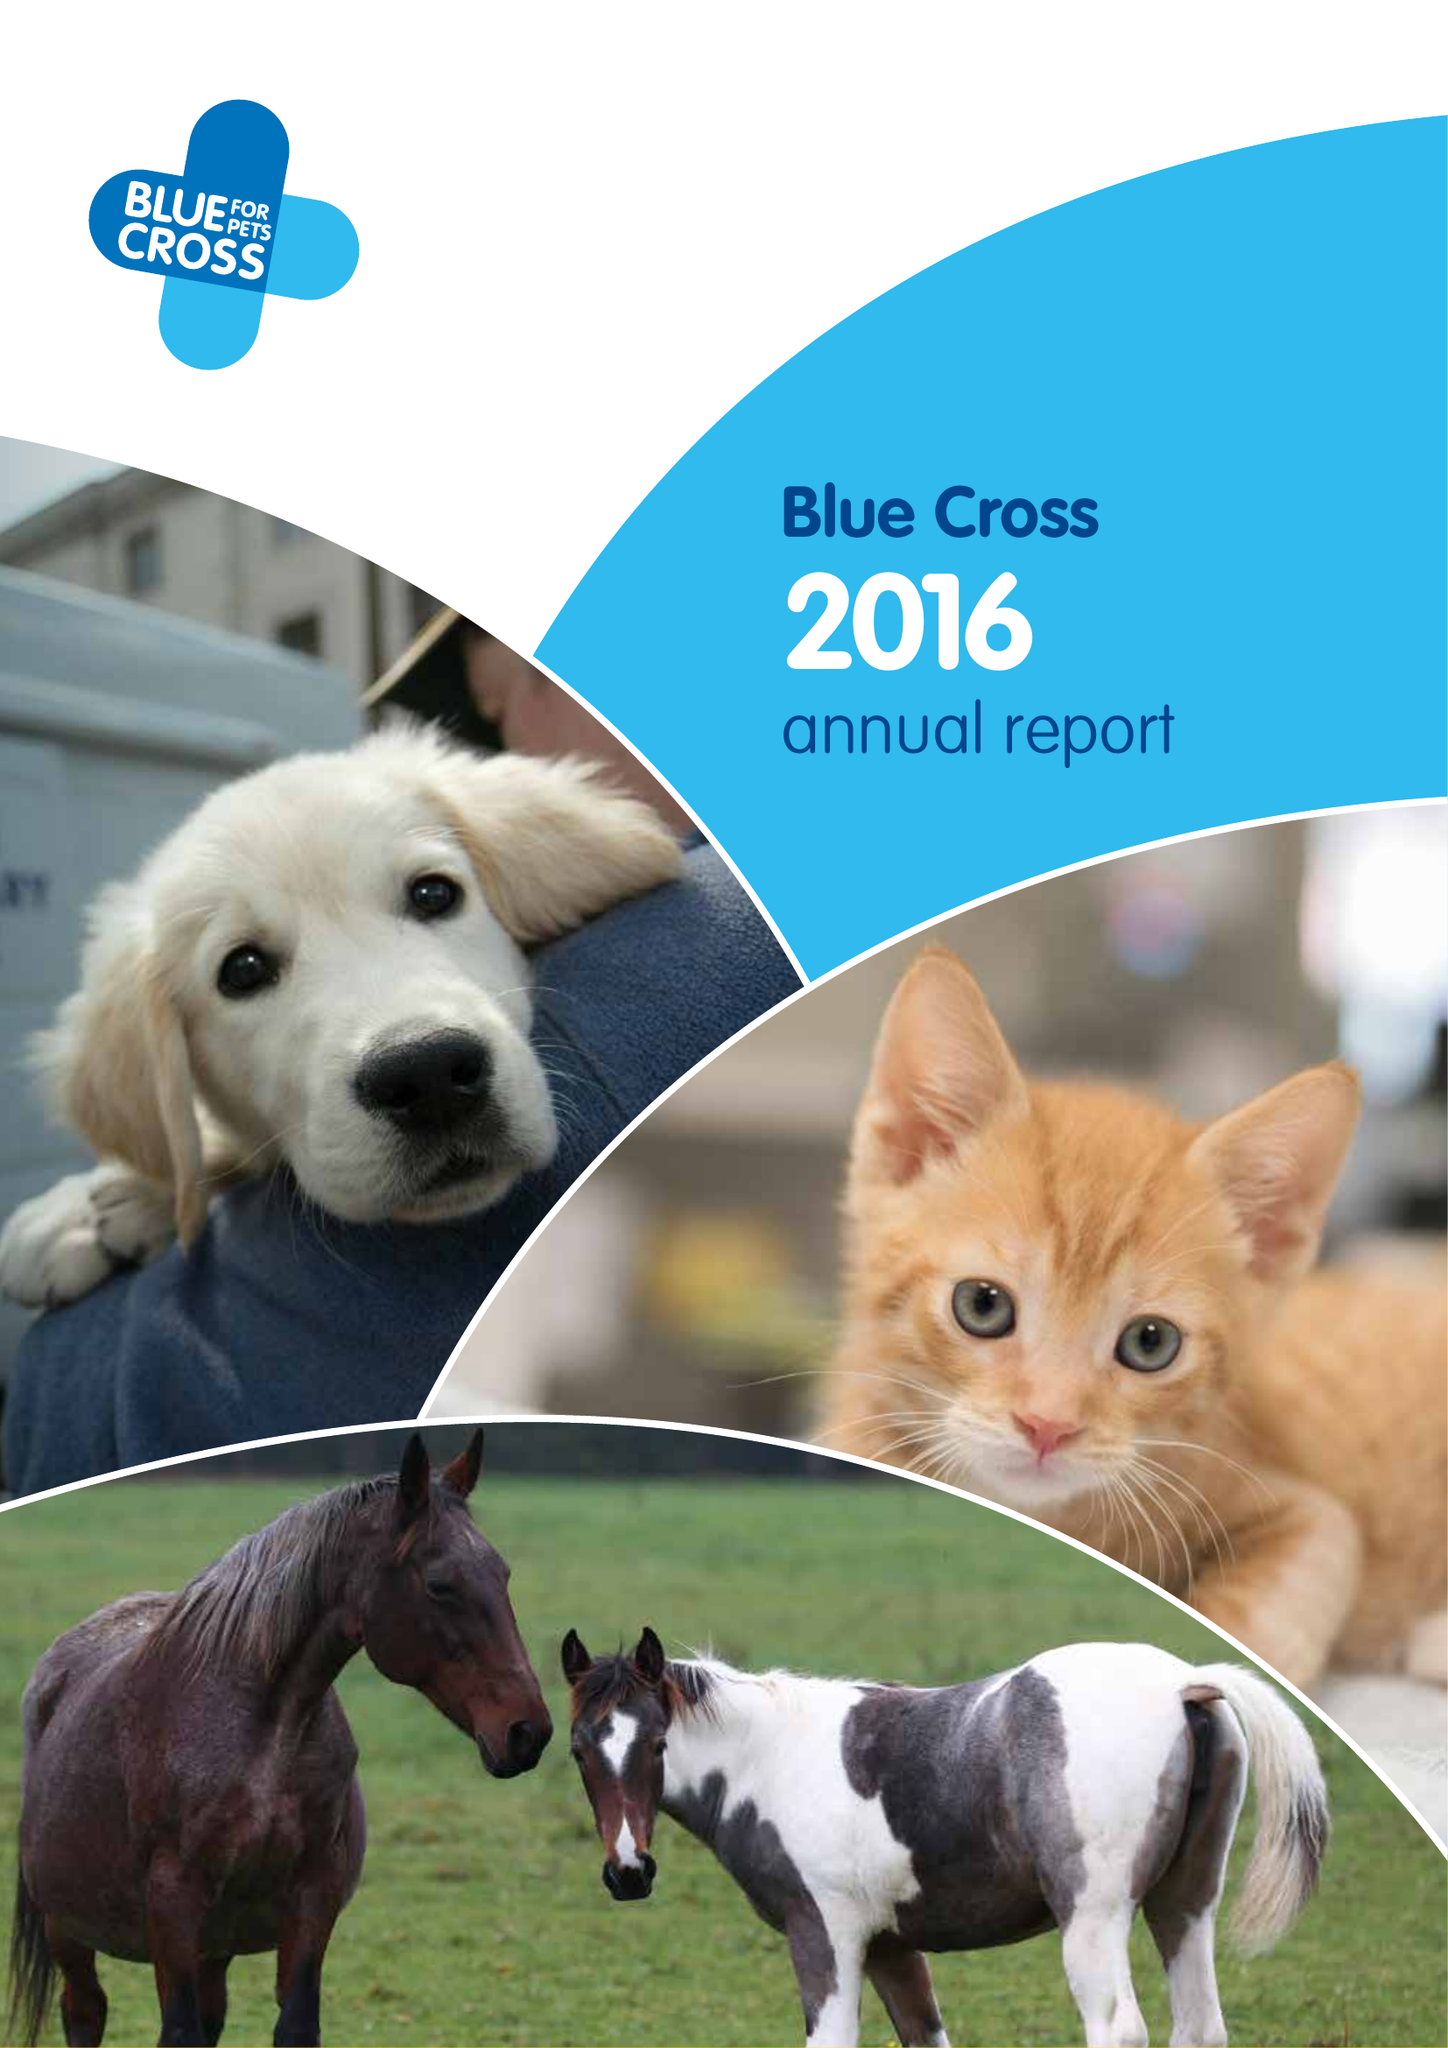What is the value for the report_date?
Answer the question using a single word or phrase. 2016-12-31 